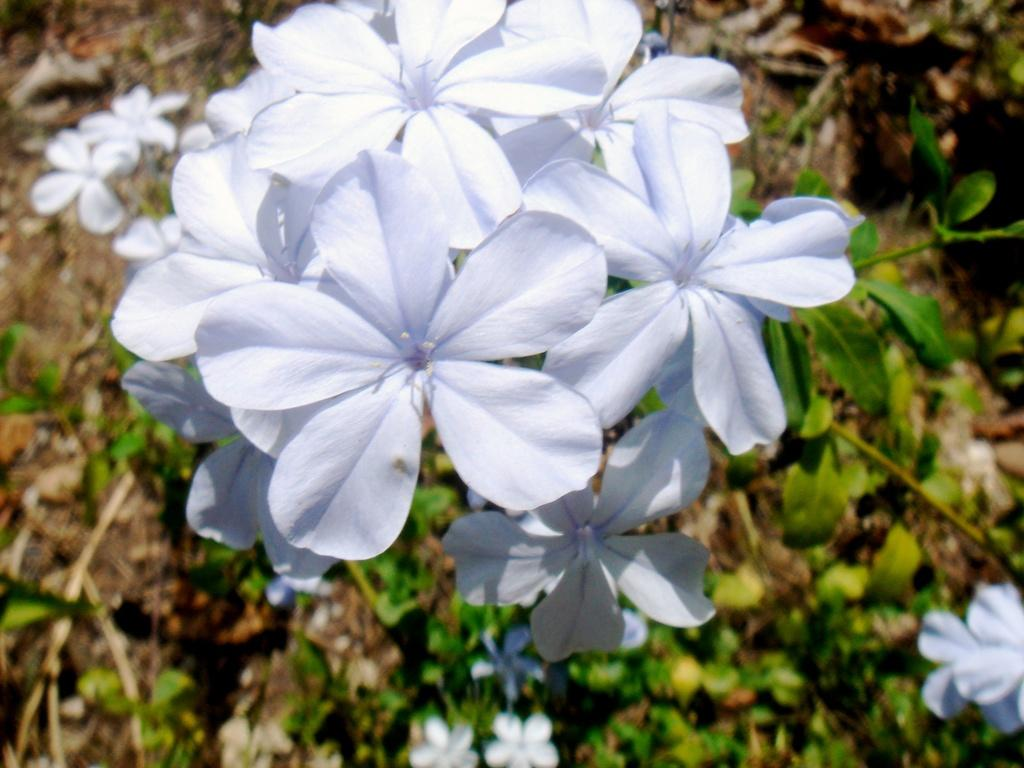What types of living organisms are in the image? The image contains plants. What specific part of the plants can be seen in the middle of the image? There are flowers in the middle of the image. What color are the flowers? The flowers are white in color. What is the aftermath of the explosion in the image? There is no explosion or aftermath present in the image; it features plants and flowers. How many times did the ground blow in the image? There is no reference to the ground blowing in the image. 